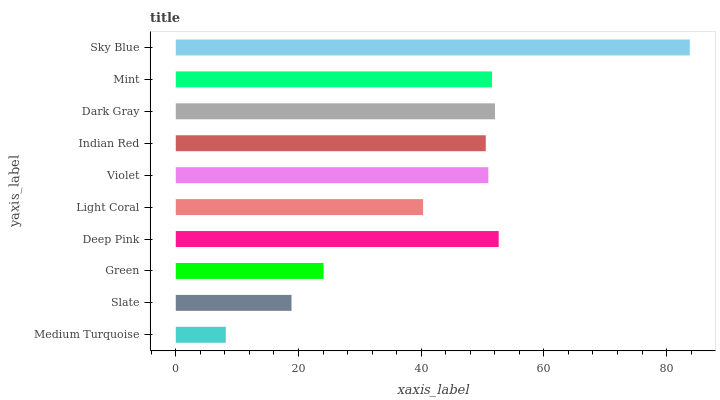Is Medium Turquoise the minimum?
Answer yes or no. Yes. Is Sky Blue the maximum?
Answer yes or no. Yes. Is Slate the minimum?
Answer yes or no. No. Is Slate the maximum?
Answer yes or no. No. Is Slate greater than Medium Turquoise?
Answer yes or no. Yes. Is Medium Turquoise less than Slate?
Answer yes or no. Yes. Is Medium Turquoise greater than Slate?
Answer yes or no. No. Is Slate less than Medium Turquoise?
Answer yes or no. No. Is Violet the high median?
Answer yes or no. Yes. Is Indian Red the low median?
Answer yes or no. Yes. Is Indian Red the high median?
Answer yes or no. No. Is Green the low median?
Answer yes or no. No. 